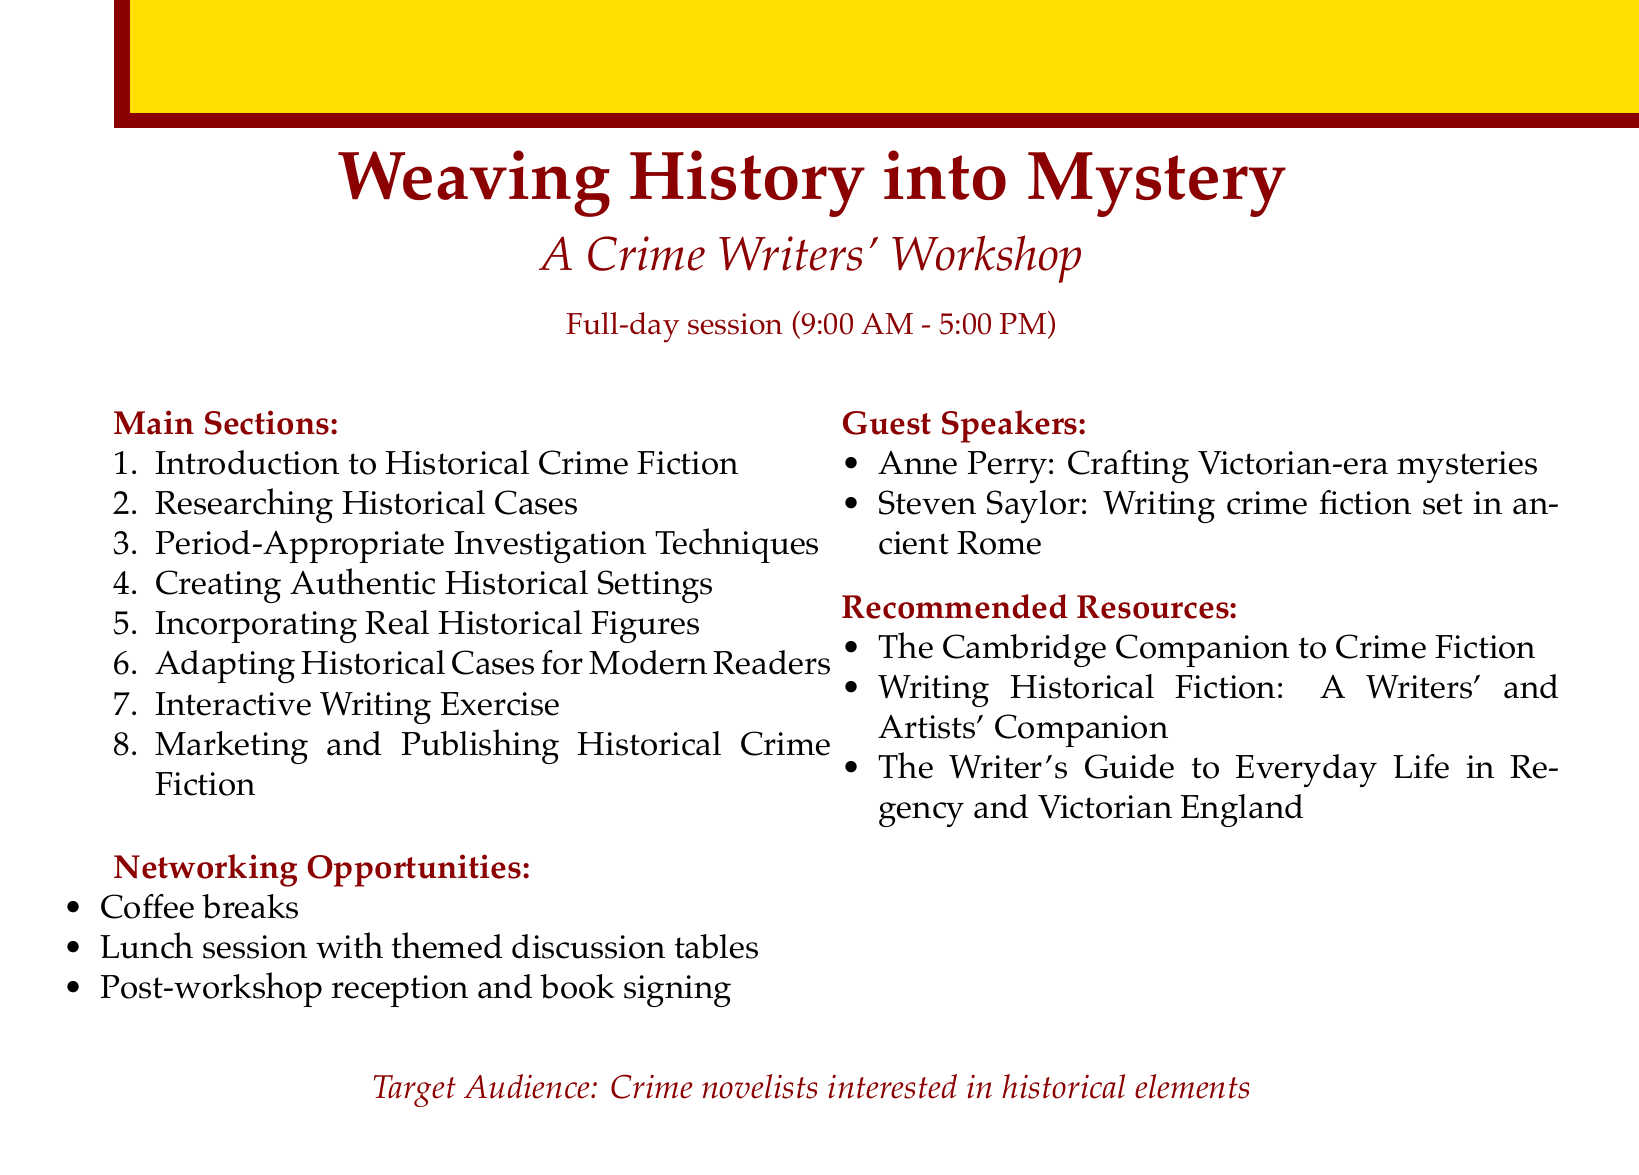What is the title of the workshop? The title can be found at the beginning of the document, which states "Weaving History into Mystery: A Crime Writers' Workshop."
Answer: Weaving History into Mystery: A Crime Writers' Workshop What is the duration of the workshop? The document specifies that it is a full-day session from 9:00 AM to 5:00 PM.
Answer: Full-day session (9:00 AM - 5:00 PM) Name one of the guest speakers. The document lists guest speakers' names, one of which is Anne Perry.
Answer: Anne Perry Which case study is mentioned under researching historical cases? The document includes the Jack the Ripper investigations as a case study in this section.
Answer: Jack the Ripper investigations How many main sections are there in the workshop agenda? By counting the listed main sections, we find there are eight sections included in the document.
Answer: 8 What is one of the interactive writing exercises mentioned? The document states participants will choose a historical crime to develop a fictional narrative around.
Answer: Choose a historical crime Which resource is recommended for understanding crime fiction? The document recommends "The Cambridge Companion to Crime Fiction" as a resource for writers.
Answer: The Cambridge Companion to Crime Fiction What networking opportunity is provided during the workshop? The document lists coffee breaks as an opportunity for networking among participants.
Answer: Coffee breaks 